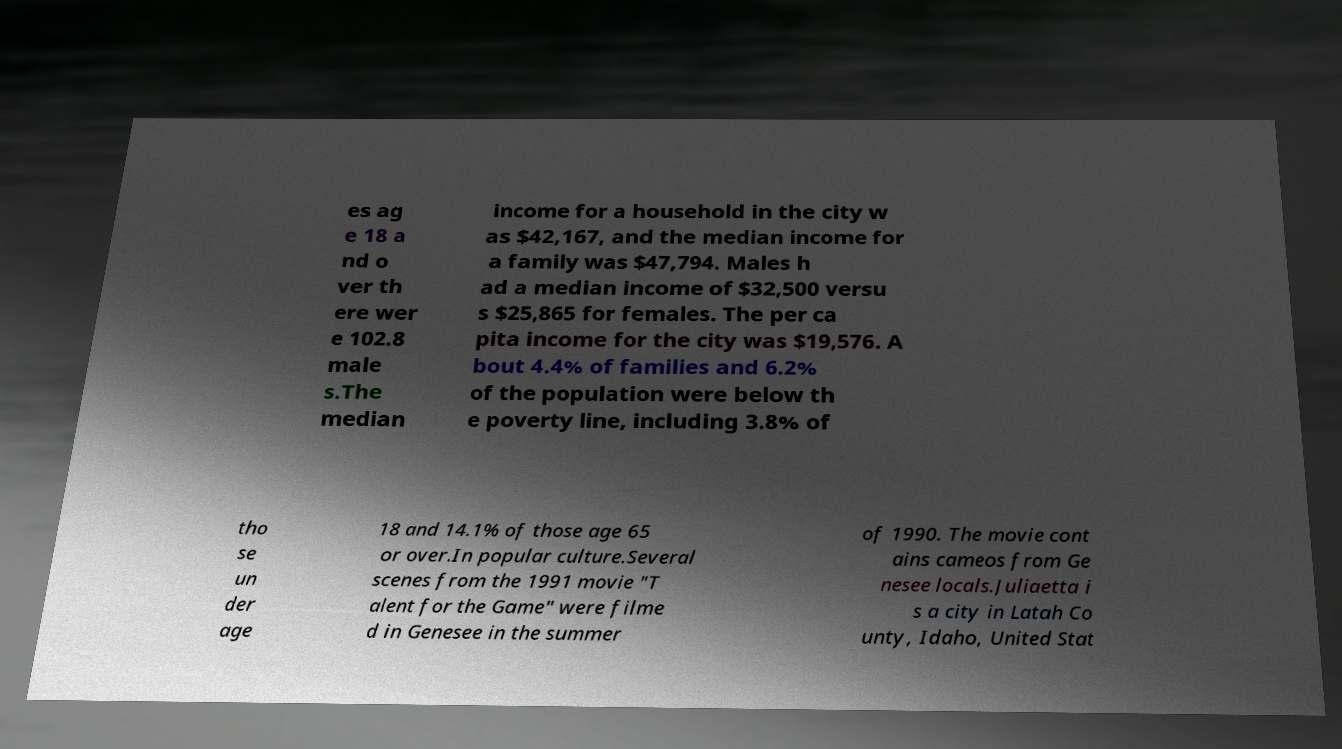I need the written content from this picture converted into text. Can you do that? es ag e 18 a nd o ver th ere wer e 102.8 male s.The median income for a household in the city w as $42,167, and the median income for a family was $47,794. Males h ad a median income of $32,500 versu s $25,865 for females. The per ca pita income for the city was $19,576. A bout 4.4% of families and 6.2% of the population were below th e poverty line, including 3.8% of tho se un der age 18 and 14.1% of those age 65 or over.In popular culture.Several scenes from the 1991 movie "T alent for the Game" were filme d in Genesee in the summer of 1990. The movie cont ains cameos from Ge nesee locals.Juliaetta i s a city in Latah Co unty, Idaho, United Stat 